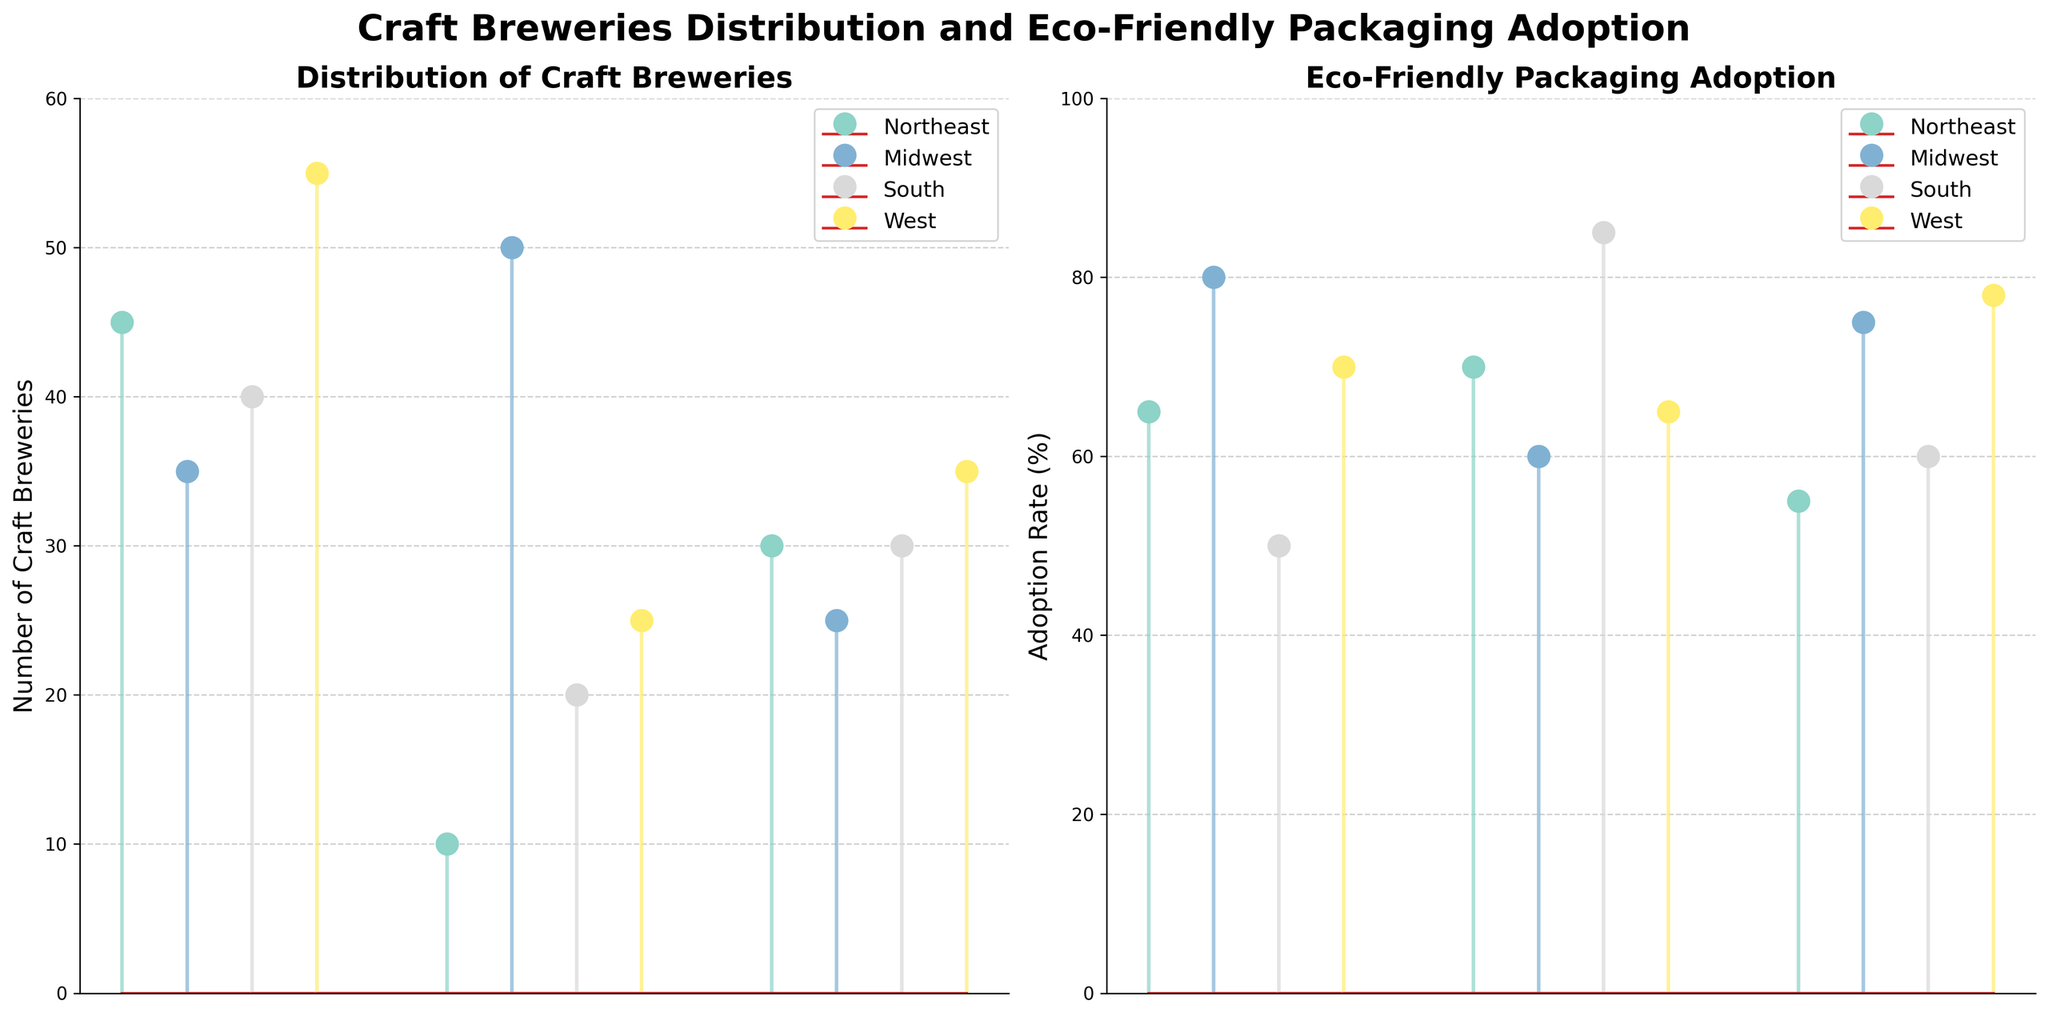What is the title of the figure? The title of the figure is located at the top and clearly states the subject of the figure as 'Craft Breweries Distribution and Eco-Friendly Packaging Adoption'.
Answer: Craft Breweries Distribution and Eco-Friendly Packaging Adoption Which region has the most craft breweries according to the figure? In the 'Distribution of Craft Breweries' subplot, the marker with the highest value corresponds to the 'West' with 55 breweries.
Answer: West What is the adoption rate of eco-friendly packaging in the South for its lowest data point? In the 'Eco-Friendly Packaging Adoption' subplot, for the South, the lowest adoption rate appears at 50%.
Answer: 50% Which region has the highest adoption rate of eco-friendly packaging? By looking at the 'Eco-Friendly Packaging Adoption' subplot, the South has the highest adoption rate at 85%.
Answer: South Compare the average number of craft breweries between the Midwest and the South. For the Midwest, the average of [35, 50, 25] is (35+50+25)/3 = 36.67. For the South, the average of [40, 20, 30] is (40+20+30)/3 = 30. Therefore, the Midwest's average is higher.
Answer: Midwest Which region shows more consistency in the number of craft breweries, and how can you tell? Consistency can be inferred by the spread of the stem values. The South region has closely grouped values (40, 20, 30), indicating more consistency than the West's (55, 25, 35).
Answer: South What is the difference between the highest and lowest adoption rates in the Midwest? The highest adoption rate in the Midwest is 80% and the lowest is 60%. The difference is 80 - 60 = 20
Answer: 20 Compare the number of craft breweries between the Northeast and the Midwest. Which region has the highest single data point? In the 'Distribution of Craft Breweries' subplot, both Northeast and Midwest have a highest single data point, but Midwest has 50 which is higher than Northeast's highest point at 45.
Answer: Midwest What is the median adoption rate of eco-friendly packaging in the West? Sorting the adoption rates for the West [70, 65, 78], the middle value is 70.
Answer: 70 Which regions' adoption rates of eco-friendly packaging vary the most? Variance can be visually inspected by the spread of the stem points. The West shows a greater range from 65% to 78% compared to other regions.
Answer: West 